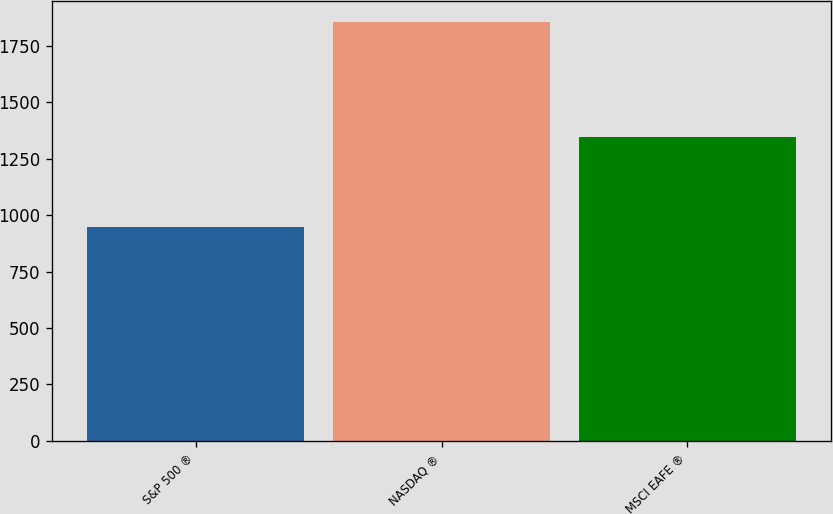<chart> <loc_0><loc_0><loc_500><loc_500><bar_chart><fcel>S&P 500 ®<fcel>NASDAQ ®<fcel>MSCI EAFE ®<nl><fcel>949<fcel>1857<fcel>1344<nl></chart> 